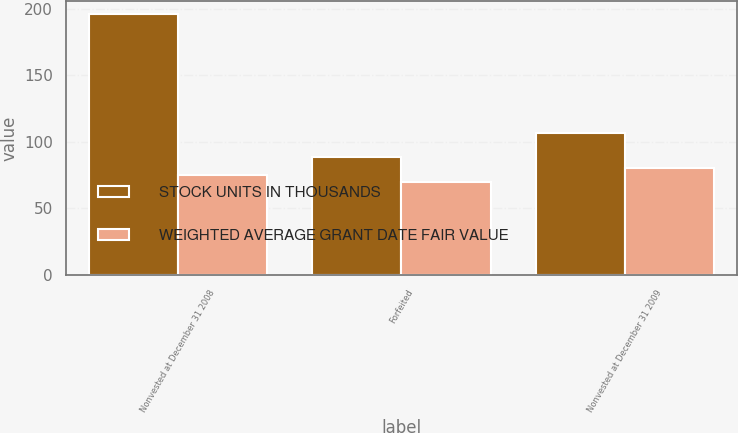Convert chart to OTSL. <chart><loc_0><loc_0><loc_500><loc_500><stacked_bar_chart><ecel><fcel>Nonvested at December 31 2008<fcel>Forfeited<fcel>Nonvested at December 31 2009<nl><fcel>STOCK UNITS IN THOUSANDS<fcel>196<fcel>89<fcel>107<nl><fcel>WEIGHTED AVERAGE GRANT DATE FAIR VALUE<fcel>75.35<fcel>69.59<fcel>80.12<nl></chart> 